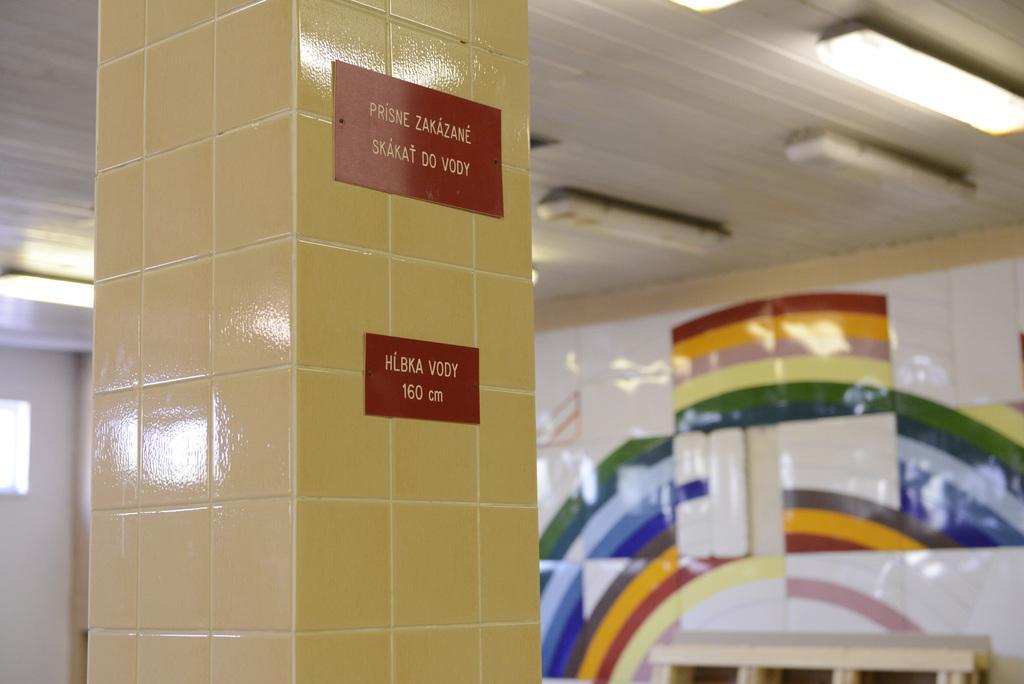Can you describe this image briefly? In the foreground of the picture there is a pillar, on the pillar there are name plates. In the background there are lights, bench and wall. 